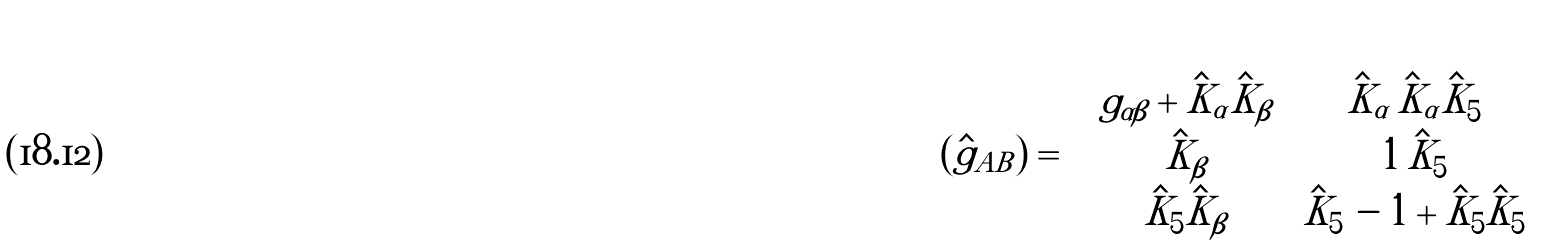<formula> <loc_0><loc_0><loc_500><loc_500>\left ( \hat { g } _ { A B } \right ) = \left ( \begin{array} { c c } g _ { \alpha \beta } + \hat { K } _ { \alpha } \hat { K } _ { \beta } \, & \, \hat { K } _ { \alpha } \, \hat { K } _ { \alpha } \hat { K } _ { 5 } \\ \hat { K } _ { \beta } \, & \, 1 \, \hat { K } _ { 5 } \\ \hat { K } _ { 5 } \hat { K } _ { \beta } \, & \, \hat { K } _ { 5 } \, - 1 + \hat { K } _ { 5 } \hat { K } _ { 5 } \end{array} \right ) \,</formula> 